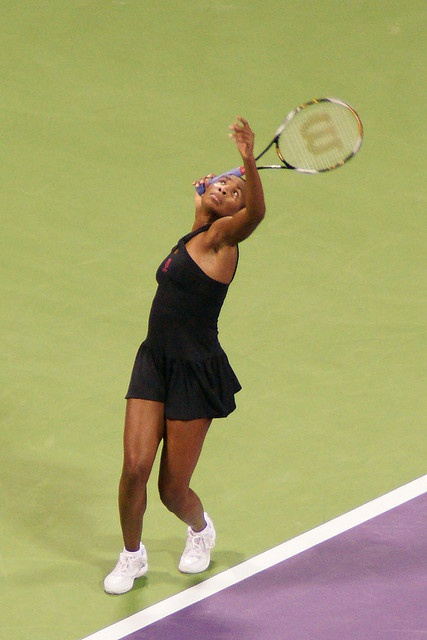Describe the objects in this image and their specific colors. I can see people in olive, black, maroon, brown, and lightgray tones and tennis racket in olive and tan tones in this image. 